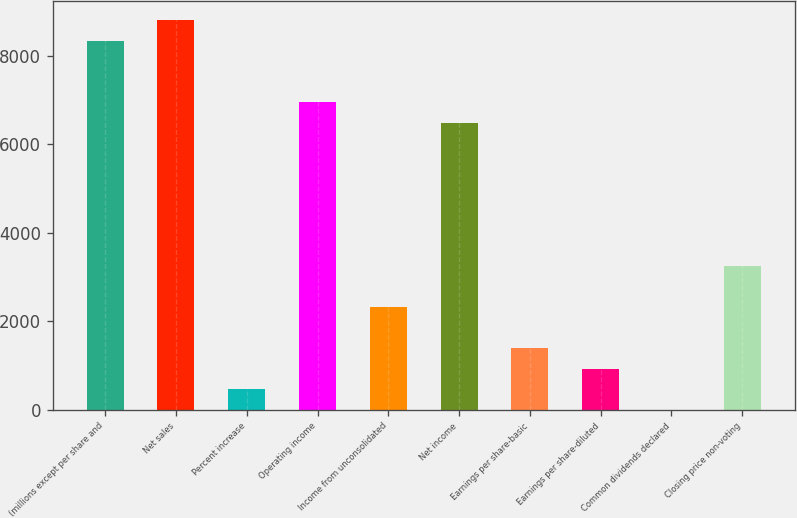<chart> <loc_0><loc_0><loc_500><loc_500><bar_chart><fcel>(millions except per share and<fcel>Net sales<fcel>Percent increase<fcel>Operating income<fcel>Income from unconsolidated<fcel>Net income<fcel>Earnings per share-basic<fcel>Earnings per share-diluted<fcel>Common dividends declared<fcel>Closing price non-voting<nl><fcel>8343.14<fcel>8806.55<fcel>465.17<fcel>6952.91<fcel>2318.81<fcel>6489.5<fcel>1391.99<fcel>928.58<fcel>1.76<fcel>3245.63<nl></chart> 